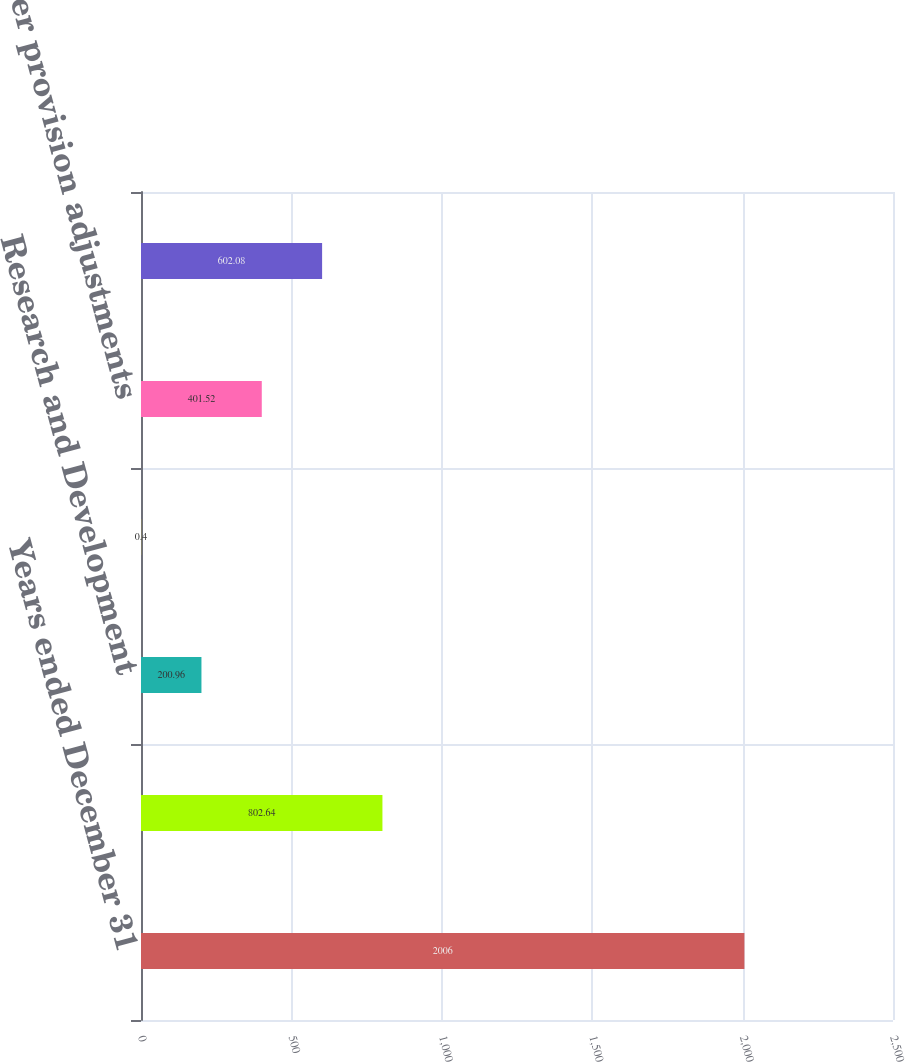Convert chart to OTSL. <chart><loc_0><loc_0><loc_500><loc_500><bar_chart><fcel>Years ended December 31<fcel>US federal statutory tax<fcel>Research and Development<fcel>State income tax provision net<fcel>Other provision adjustments<fcel>Income tax expense<nl><fcel>2006<fcel>802.64<fcel>200.96<fcel>0.4<fcel>401.52<fcel>602.08<nl></chart> 